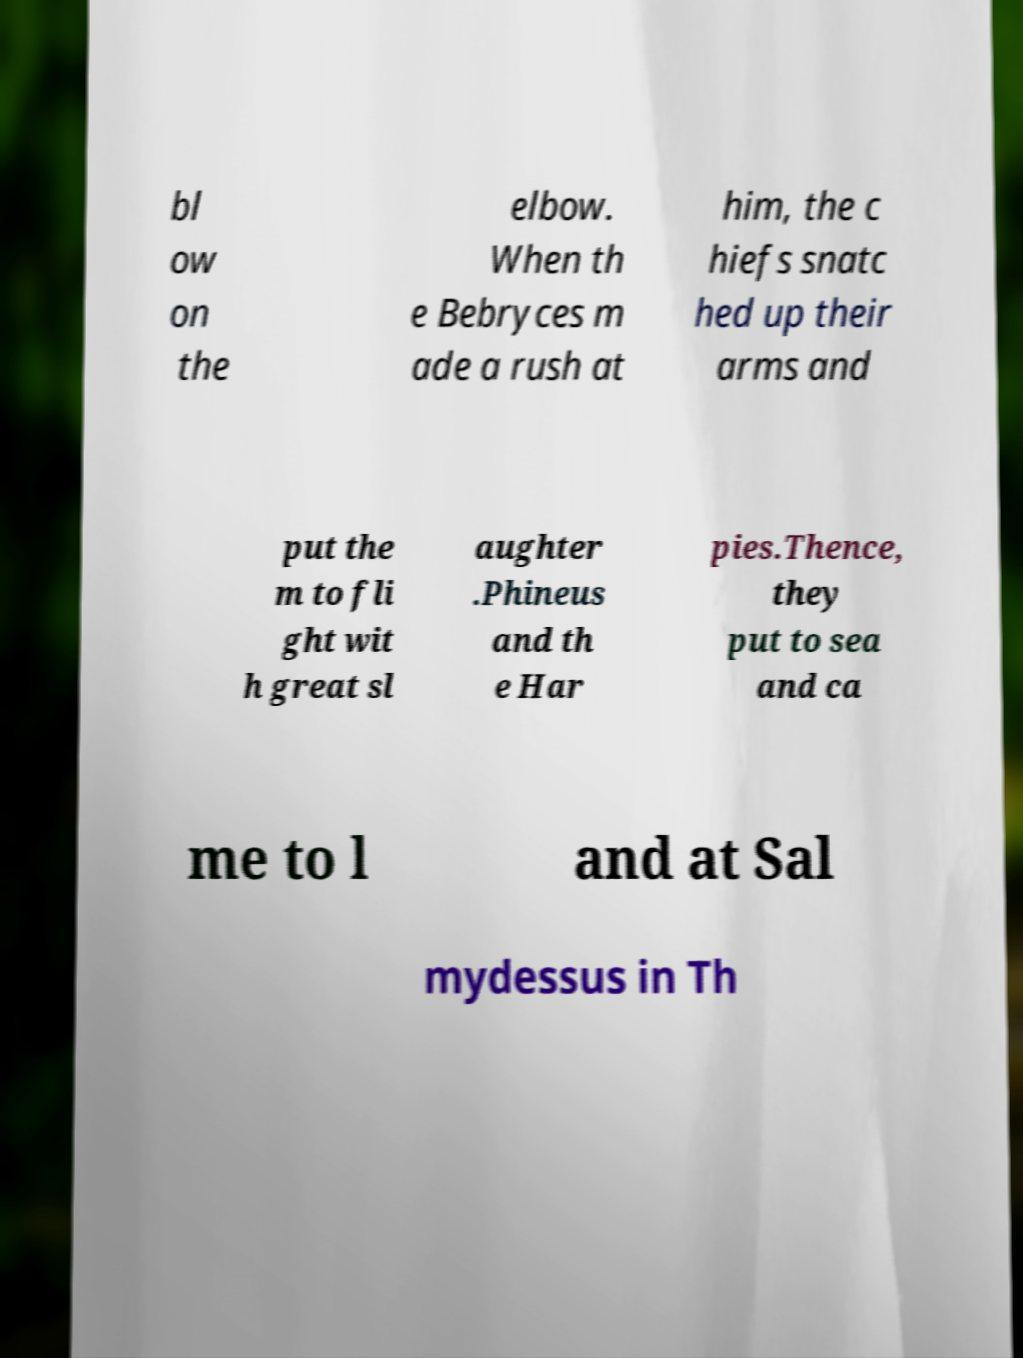There's text embedded in this image that I need extracted. Can you transcribe it verbatim? bl ow on the elbow. When th e Bebryces m ade a rush at him, the c hiefs snatc hed up their arms and put the m to fli ght wit h great sl aughter .Phineus and th e Har pies.Thence, they put to sea and ca me to l and at Sal mydessus in Th 